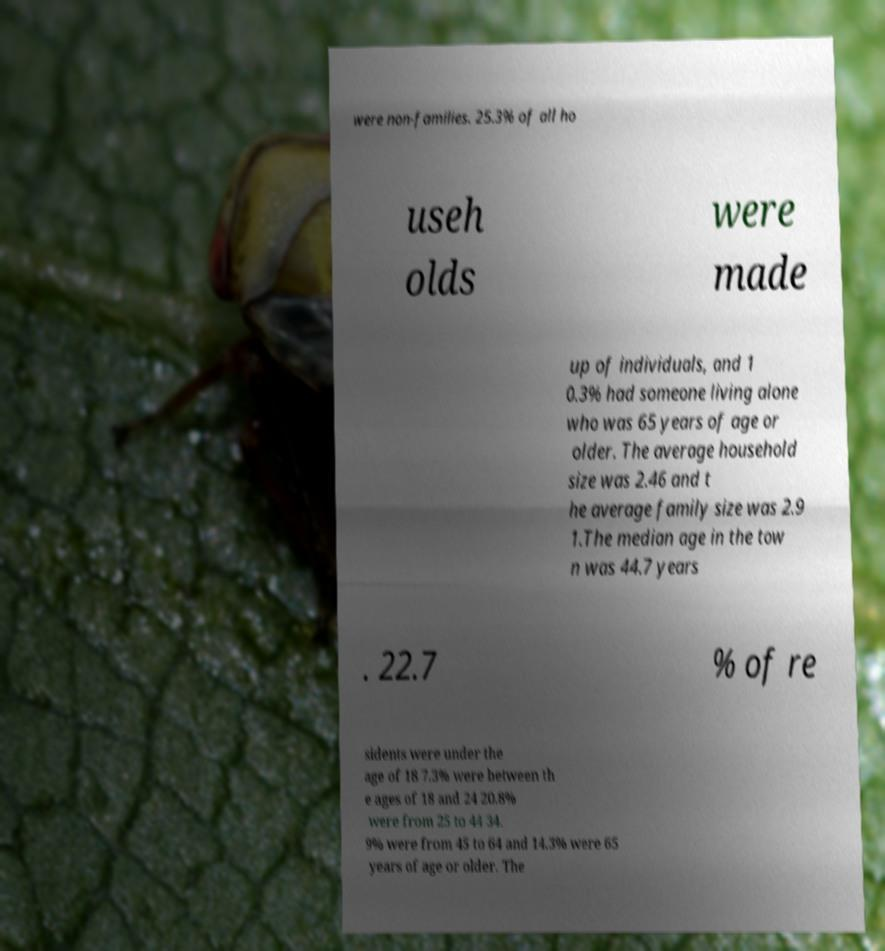For documentation purposes, I need the text within this image transcribed. Could you provide that? were non-families. 25.3% of all ho useh olds were made up of individuals, and 1 0.3% had someone living alone who was 65 years of age or older. The average household size was 2.46 and t he average family size was 2.9 1.The median age in the tow n was 44.7 years . 22.7 % of re sidents were under the age of 18 7.3% were between th e ages of 18 and 24 20.8% were from 25 to 44 34. 9% were from 45 to 64 and 14.3% were 65 years of age or older. The 